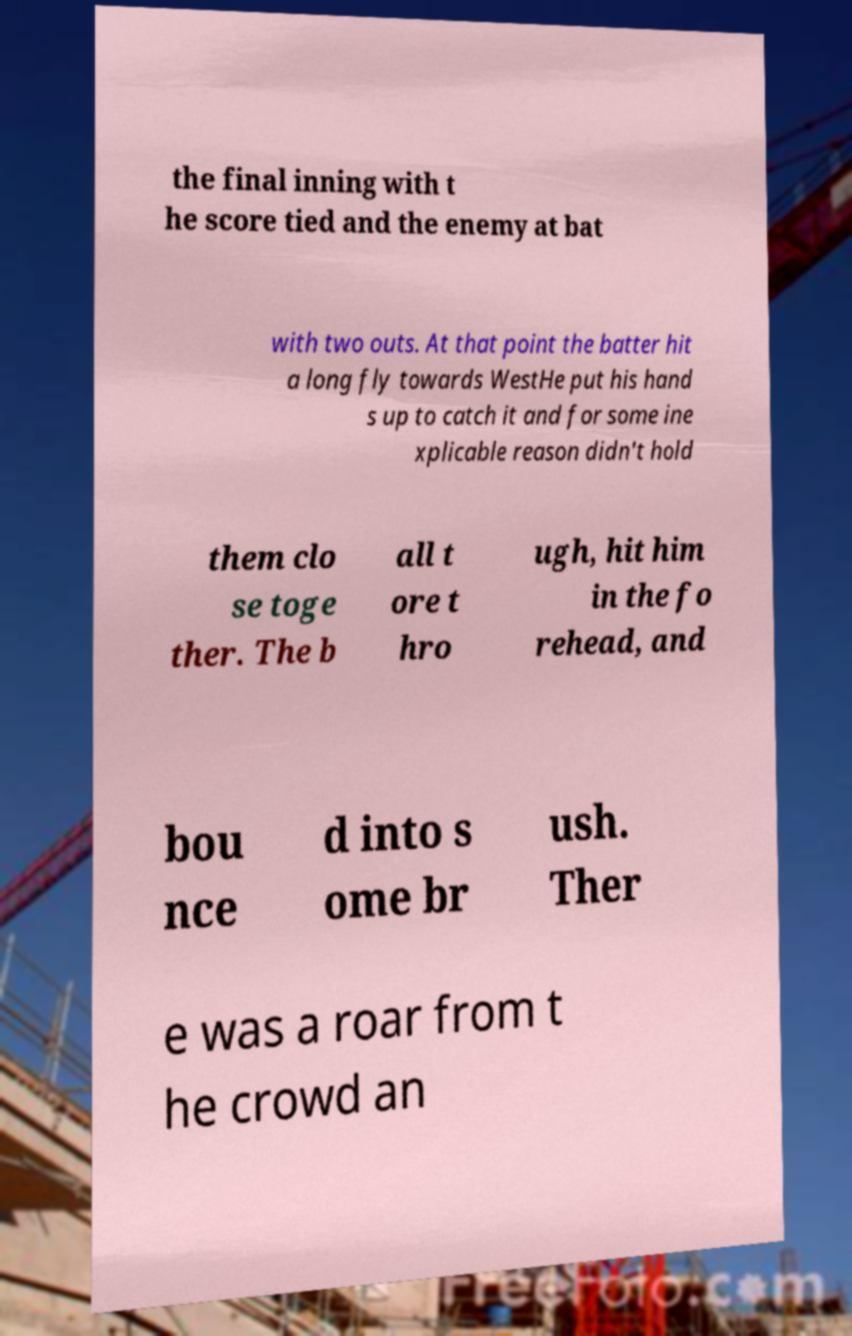Can you read and provide the text displayed in the image?This photo seems to have some interesting text. Can you extract and type it out for me? the final inning with t he score tied and the enemy at bat with two outs. At that point the batter hit a long fly towards WestHe put his hand s up to catch it and for some ine xplicable reason didn't hold them clo se toge ther. The b all t ore t hro ugh, hit him in the fo rehead, and bou nce d into s ome br ush. Ther e was a roar from t he crowd an 